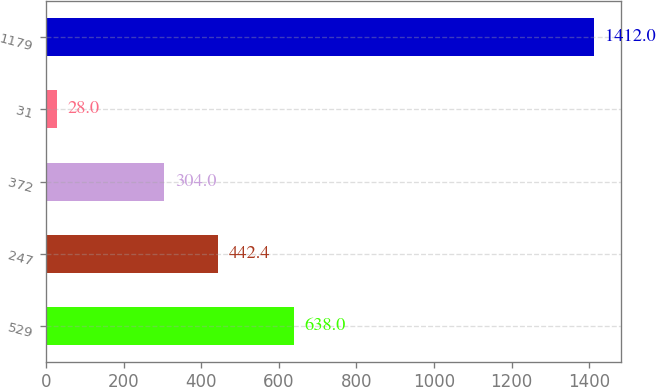<chart> <loc_0><loc_0><loc_500><loc_500><bar_chart><fcel>529<fcel>247<fcel>372<fcel>31<fcel>1179<nl><fcel>638<fcel>442.4<fcel>304<fcel>28<fcel>1412<nl></chart> 